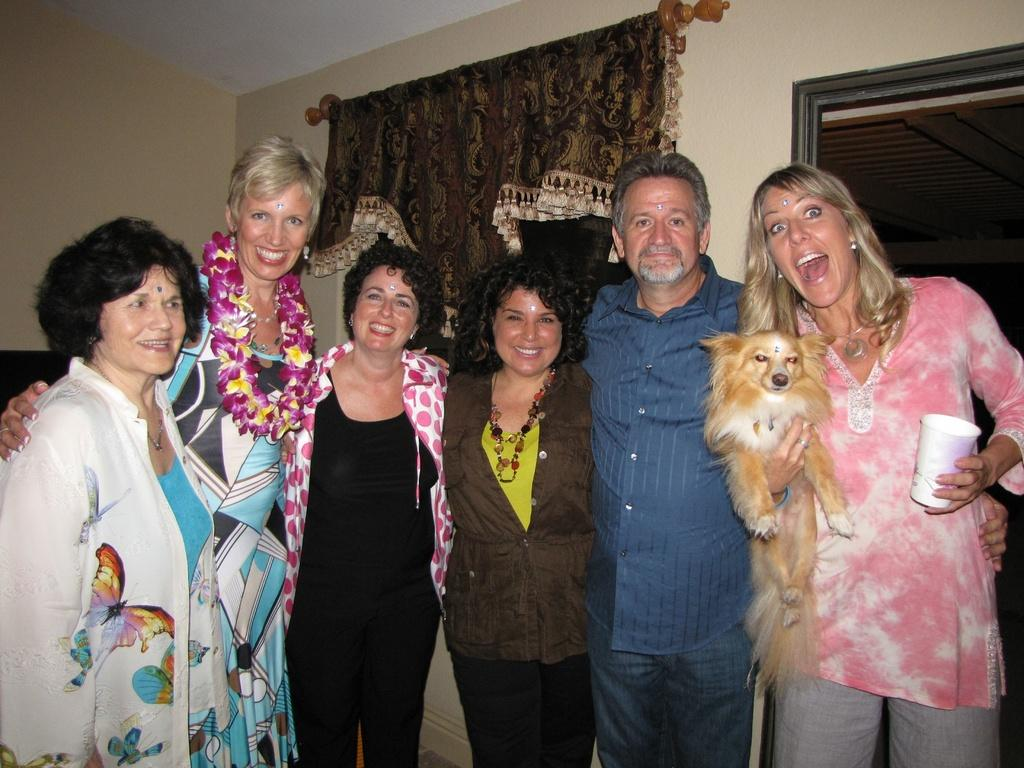What are the people in the image doing? The people in the image are standing and smiling. Can you describe the woman in the right corner? The woman in the right corner is holding a dog and a glass in her hands. What can be seen in the background of the image? There is a wall and a curtain in the background of the image. What type of fowl is sitting on the tray in the image? There is no tray or fowl present in the image. 